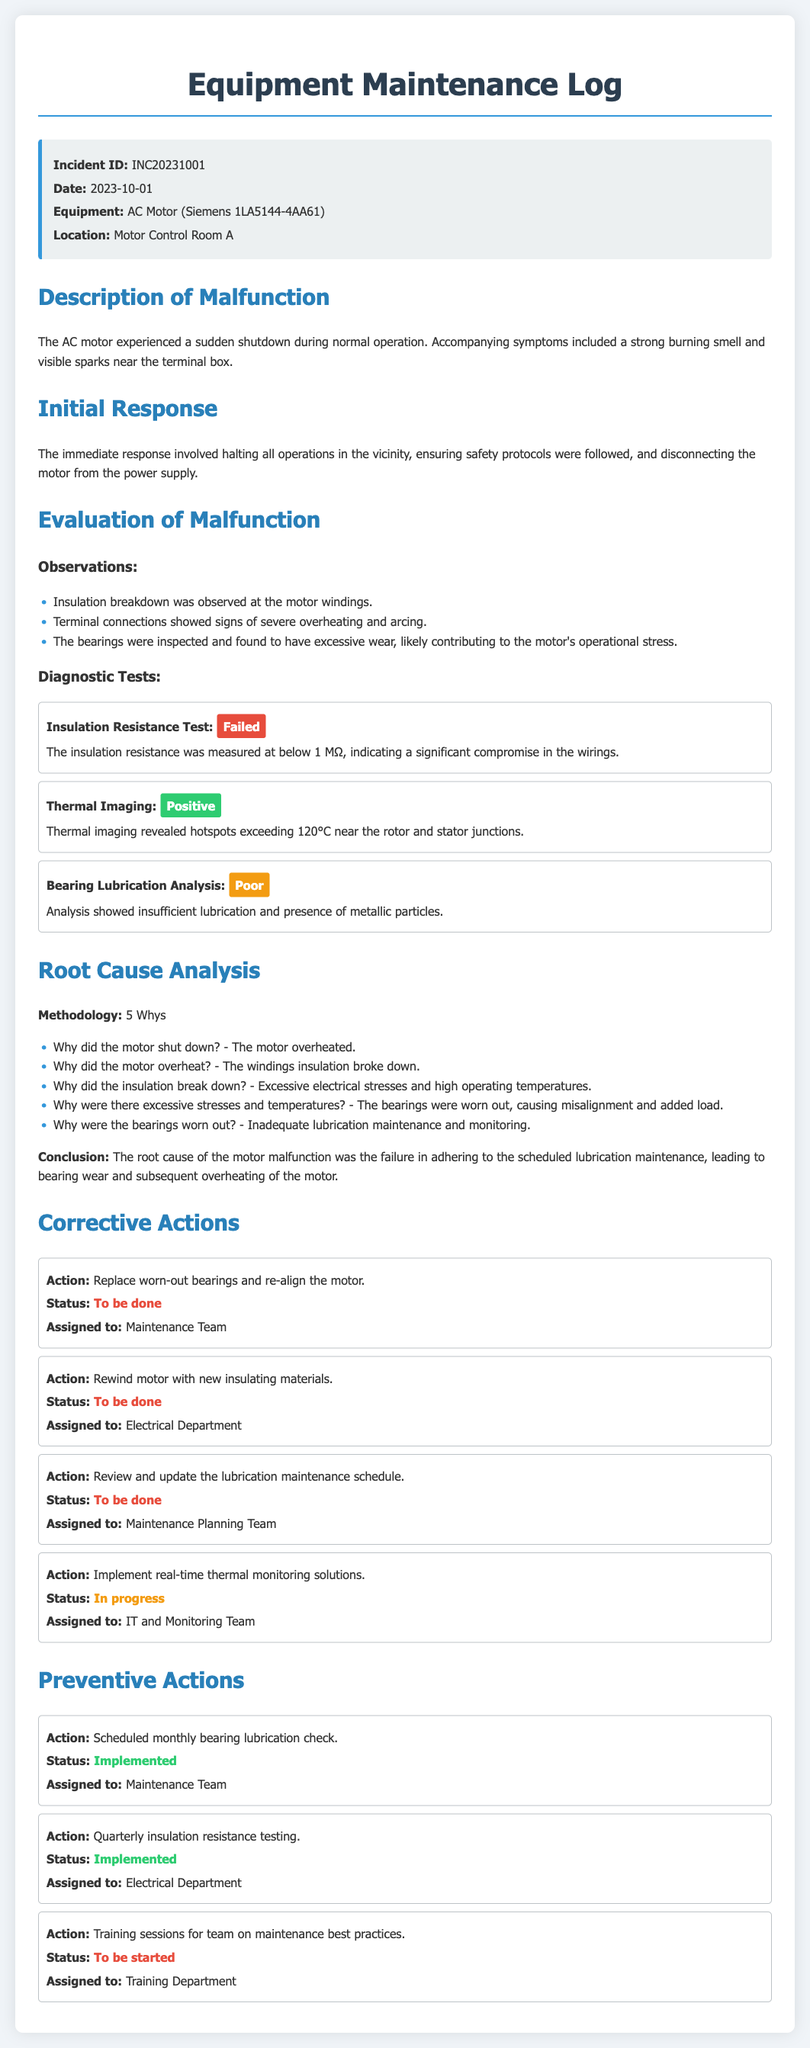What is the Incident ID? The Incident ID is specified at the beginning of the document, indicating the unique reference for the maintenance log entry.
Answer: INC20231001 What equipment experienced a malfunction? The document lists the specific equipment that faced issues, which is crucial for identifying the context of the incident.
Answer: AC Motor (Siemens 1LA5144-4AA61) What was observed at the motor windings? This question aims to extract specific observation details that contributed to understanding the malfunction.
Answer: Insulation breakdown What was the conclusion of the root cause analysis? The conclusion sums up the findings from the root cause analysis, making it a key takeaway from the evaluation.
Answer: The root cause of the motor malfunction was the failure in adhering to the scheduled lubrication maintenance Which action is currently in progress? Identifying the status of corrective actions helps in tracking the steps taken after the malfunction was recorded.
Answer: Implement real-time thermal monitoring solutions What was the status of the insulation resistance test? This question addresses the results of the diagnostic tests conducted, which are vital for assessing the condition of the motor.
Answer: Failed How often should the bearing lubrication be checked? This question relates to preventive actions outlined in the log, revealing the maintenance frequency to avoid future issues.
Answer: Monthly Who is assigned to the action of rewinding the motor? Understanding who is responsible for specific corrective actions aids in accountability.
Answer: Electrical Department What symptom accompanied the motor shutdown? This question reveals important details about the conditions present during the malfunction, crucial for future prevention.
Answer: Strong burning smell and visible sparks 